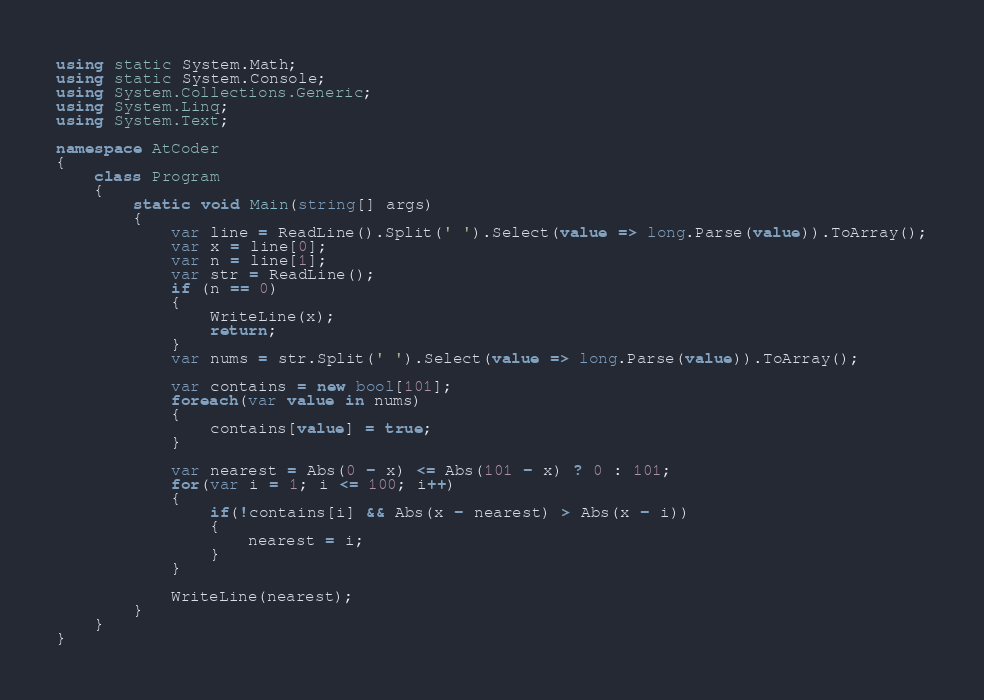<code> <loc_0><loc_0><loc_500><loc_500><_C#_>using static System.Math;
using static System.Console;
using System.Collections.Generic;
using System.Linq;
using System.Text;

namespace AtCoder
{
    class Program
    {
        static void Main(string[] args)
        {
            var line = ReadLine().Split(' ').Select(value => long.Parse(value)).ToArray();
            var x = line[0];
            var n = line[1];
            var str = ReadLine();
            if (n == 0)
            {
                WriteLine(x);
                return;
            }
            var nums = str.Split(' ').Select(value => long.Parse(value)).ToArray();

            var contains = new bool[101];
            foreach(var value in nums)
            {
                contains[value] = true;
            }

            var nearest = Abs(0 - x) <= Abs(101 - x) ? 0 : 101;
            for(var i = 1; i <= 100; i++)
            {
                if(!contains[i] && Abs(x - nearest) > Abs(x - i))
                {
                    nearest = i;
                }
            }

            WriteLine(nearest);
        }
    }
}
</code> 